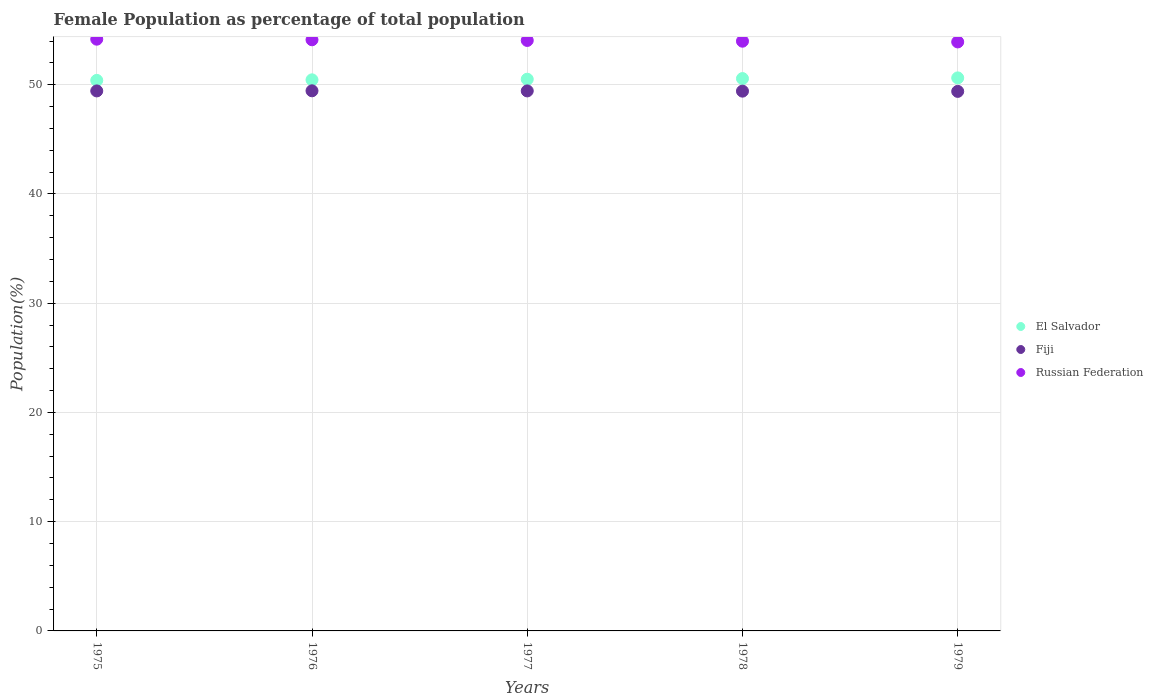How many different coloured dotlines are there?
Provide a short and direct response. 3. What is the female population in in Fiji in 1978?
Your answer should be very brief. 49.41. Across all years, what is the maximum female population in in Russian Federation?
Provide a short and direct response. 54.17. Across all years, what is the minimum female population in in Fiji?
Give a very brief answer. 49.39. In which year was the female population in in Russian Federation maximum?
Ensure brevity in your answer.  1975. In which year was the female population in in El Salvador minimum?
Your response must be concise. 1975. What is the total female population in in Fiji in the graph?
Make the answer very short. 247.11. What is the difference between the female population in in Russian Federation in 1975 and that in 1977?
Give a very brief answer. 0.12. What is the difference between the female population in in Russian Federation in 1975 and the female population in in El Salvador in 1976?
Your answer should be compact. 3.72. What is the average female population in in Russian Federation per year?
Provide a short and direct response. 54.05. In the year 1979, what is the difference between the female population in in El Salvador and female population in in Russian Federation?
Make the answer very short. -3.29. In how many years, is the female population in in El Salvador greater than 22 %?
Offer a terse response. 5. What is the ratio of the female population in in Russian Federation in 1975 to that in 1976?
Keep it short and to the point. 1. What is the difference between the highest and the second highest female population in in Fiji?
Give a very brief answer. 0.01. What is the difference between the highest and the lowest female population in in Fiji?
Keep it short and to the point. 0.05. What is the difference between two consecutive major ticks on the Y-axis?
Make the answer very short. 10. Are the values on the major ticks of Y-axis written in scientific E-notation?
Your answer should be very brief. No. Does the graph contain any zero values?
Your response must be concise. No. Does the graph contain grids?
Keep it short and to the point. Yes. Where does the legend appear in the graph?
Make the answer very short. Center right. How many legend labels are there?
Provide a succinct answer. 3. How are the legend labels stacked?
Give a very brief answer. Vertical. What is the title of the graph?
Offer a terse response. Female Population as percentage of total population. What is the label or title of the Y-axis?
Your answer should be very brief. Population(%). What is the Population(%) of El Salvador in 1975?
Make the answer very short. 50.4. What is the Population(%) of Fiji in 1975?
Keep it short and to the point. 49.43. What is the Population(%) of Russian Federation in 1975?
Provide a succinct answer. 54.17. What is the Population(%) of El Salvador in 1976?
Make the answer very short. 50.45. What is the Population(%) of Fiji in 1976?
Ensure brevity in your answer.  49.44. What is the Population(%) in Russian Federation in 1976?
Provide a succinct answer. 54.11. What is the Population(%) of El Salvador in 1977?
Your response must be concise. 50.5. What is the Population(%) in Fiji in 1977?
Make the answer very short. 49.43. What is the Population(%) in Russian Federation in 1977?
Make the answer very short. 54.05. What is the Population(%) in El Salvador in 1978?
Give a very brief answer. 50.56. What is the Population(%) in Fiji in 1978?
Offer a very short reply. 49.41. What is the Population(%) of Russian Federation in 1978?
Provide a succinct answer. 53.98. What is the Population(%) of El Salvador in 1979?
Offer a very short reply. 50.62. What is the Population(%) of Fiji in 1979?
Your response must be concise. 49.39. What is the Population(%) of Russian Federation in 1979?
Your response must be concise. 53.92. Across all years, what is the maximum Population(%) of El Salvador?
Provide a succinct answer. 50.62. Across all years, what is the maximum Population(%) in Fiji?
Your answer should be compact. 49.44. Across all years, what is the maximum Population(%) in Russian Federation?
Ensure brevity in your answer.  54.17. Across all years, what is the minimum Population(%) of El Salvador?
Provide a short and direct response. 50.4. Across all years, what is the minimum Population(%) of Fiji?
Ensure brevity in your answer.  49.39. Across all years, what is the minimum Population(%) in Russian Federation?
Offer a very short reply. 53.92. What is the total Population(%) of El Salvador in the graph?
Your response must be concise. 252.53. What is the total Population(%) of Fiji in the graph?
Make the answer very short. 247.11. What is the total Population(%) of Russian Federation in the graph?
Give a very brief answer. 270.24. What is the difference between the Population(%) in El Salvador in 1975 and that in 1976?
Keep it short and to the point. -0.05. What is the difference between the Population(%) in Fiji in 1975 and that in 1976?
Offer a very short reply. -0.01. What is the difference between the Population(%) in Russian Federation in 1975 and that in 1976?
Provide a short and direct response. 0.05. What is the difference between the Population(%) in El Salvador in 1975 and that in 1977?
Give a very brief answer. -0.11. What is the difference between the Population(%) in Fiji in 1975 and that in 1977?
Provide a short and direct response. -0. What is the difference between the Population(%) of Russian Federation in 1975 and that in 1977?
Keep it short and to the point. 0.12. What is the difference between the Population(%) of El Salvador in 1975 and that in 1978?
Provide a short and direct response. -0.17. What is the difference between the Population(%) in Fiji in 1975 and that in 1978?
Make the answer very short. 0.02. What is the difference between the Population(%) in Russian Federation in 1975 and that in 1978?
Give a very brief answer. 0.18. What is the difference between the Population(%) of El Salvador in 1975 and that in 1979?
Make the answer very short. -0.23. What is the difference between the Population(%) in Fiji in 1975 and that in 1979?
Make the answer very short. 0.04. What is the difference between the Population(%) in Russian Federation in 1975 and that in 1979?
Your answer should be very brief. 0.25. What is the difference between the Population(%) in El Salvador in 1976 and that in 1977?
Keep it short and to the point. -0.06. What is the difference between the Population(%) of Fiji in 1976 and that in 1977?
Offer a terse response. 0.01. What is the difference between the Population(%) of Russian Federation in 1976 and that in 1977?
Provide a succinct answer. 0.06. What is the difference between the Population(%) in El Salvador in 1976 and that in 1978?
Keep it short and to the point. -0.12. What is the difference between the Population(%) of Fiji in 1976 and that in 1978?
Your answer should be compact. 0.03. What is the difference between the Population(%) of Russian Federation in 1976 and that in 1978?
Your answer should be compact. 0.13. What is the difference between the Population(%) of El Salvador in 1976 and that in 1979?
Make the answer very short. -0.18. What is the difference between the Population(%) in Fiji in 1976 and that in 1979?
Ensure brevity in your answer.  0.05. What is the difference between the Population(%) of Russian Federation in 1976 and that in 1979?
Offer a very short reply. 0.2. What is the difference between the Population(%) of El Salvador in 1977 and that in 1978?
Ensure brevity in your answer.  -0.06. What is the difference between the Population(%) of Fiji in 1977 and that in 1978?
Give a very brief answer. 0.02. What is the difference between the Population(%) in Russian Federation in 1977 and that in 1978?
Keep it short and to the point. 0.07. What is the difference between the Population(%) of El Salvador in 1977 and that in 1979?
Give a very brief answer. -0.12. What is the difference between the Population(%) of Fiji in 1977 and that in 1979?
Keep it short and to the point. 0.04. What is the difference between the Population(%) of Russian Federation in 1977 and that in 1979?
Offer a terse response. 0.13. What is the difference between the Population(%) of El Salvador in 1978 and that in 1979?
Offer a terse response. -0.06. What is the difference between the Population(%) of Fiji in 1978 and that in 1979?
Make the answer very short. 0.02. What is the difference between the Population(%) of Russian Federation in 1978 and that in 1979?
Keep it short and to the point. 0.07. What is the difference between the Population(%) of El Salvador in 1975 and the Population(%) of Fiji in 1976?
Provide a succinct answer. 0.95. What is the difference between the Population(%) in El Salvador in 1975 and the Population(%) in Russian Federation in 1976?
Your answer should be very brief. -3.72. What is the difference between the Population(%) of Fiji in 1975 and the Population(%) of Russian Federation in 1976?
Keep it short and to the point. -4.68. What is the difference between the Population(%) of El Salvador in 1975 and the Population(%) of Fiji in 1977?
Ensure brevity in your answer.  0.96. What is the difference between the Population(%) of El Salvador in 1975 and the Population(%) of Russian Federation in 1977?
Your answer should be very brief. -3.66. What is the difference between the Population(%) in Fiji in 1975 and the Population(%) in Russian Federation in 1977?
Make the answer very short. -4.62. What is the difference between the Population(%) in El Salvador in 1975 and the Population(%) in Fiji in 1978?
Your answer should be compact. 0.98. What is the difference between the Population(%) in El Salvador in 1975 and the Population(%) in Russian Federation in 1978?
Your answer should be compact. -3.59. What is the difference between the Population(%) in Fiji in 1975 and the Population(%) in Russian Federation in 1978?
Offer a very short reply. -4.55. What is the difference between the Population(%) in El Salvador in 1975 and the Population(%) in Fiji in 1979?
Your answer should be very brief. 1.01. What is the difference between the Population(%) in El Salvador in 1975 and the Population(%) in Russian Federation in 1979?
Keep it short and to the point. -3.52. What is the difference between the Population(%) of Fiji in 1975 and the Population(%) of Russian Federation in 1979?
Offer a very short reply. -4.49. What is the difference between the Population(%) in El Salvador in 1976 and the Population(%) in Russian Federation in 1977?
Keep it short and to the point. -3.6. What is the difference between the Population(%) in Fiji in 1976 and the Population(%) in Russian Federation in 1977?
Keep it short and to the point. -4.61. What is the difference between the Population(%) of El Salvador in 1976 and the Population(%) of Fiji in 1978?
Keep it short and to the point. 1.04. What is the difference between the Population(%) of El Salvador in 1976 and the Population(%) of Russian Federation in 1978?
Give a very brief answer. -3.54. What is the difference between the Population(%) in Fiji in 1976 and the Population(%) in Russian Federation in 1978?
Your answer should be very brief. -4.54. What is the difference between the Population(%) of El Salvador in 1976 and the Population(%) of Fiji in 1979?
Ensure brevity in your answer.  1.06. What is the difference between the Population(%) in El Salvador in 1976 and the Population(%) in Russian Federation in 1979?
Provide a succinct answer. -3.47. What is the difference between the Population(%) in Fiji in 1976 and the Population(%) in Russian Federation in 1979?
Offer a very short reply. -4.47. What is the difference between the Population(%) of El Salvador in 1977 and the Population(%) of Fiji in 1978?
Offer a very short reply. 1.09. What is the difference between the Population(%) of El Salvador in 1977 and the Population(%) of Russian Federation in 1978?
Your answer should be very brief. -3.48. What is the difference between the Population(%) of Fiji in 1977 and the Population(%) of Russian Federation in 1978?
Your answer should be compact. -4.55. What is the difference between the Population(%) of El Salvador in 1977 and the Population(%) of Fiji in 1979?
Give a very brief answer. 1.11. What is the difference between the Population(%) of El Salvador in 1977 and the Population(%) of Russian Federation in 1979?
Ensure brevity in your answer.  -3.41. What is the difference between the Population(%) in Fiji in 1977 and the Population(%) in Russian Federation in 1979?
Your answer should be compact. -4.48. What is the difference between the Population(%) of El Salvador in 1978 and the Population(%) of Fiji in 1979?
Keep it short and to the point. 1.17. What is the difference between the Population(%) of El Salvador in 1978 and the Population(%) of Russian Federation in 1979?
Provide a short and direct response. -3.35. What is the difference between the Population(%) of Fiji in 1978 and the Population(%) of Russian Federation in 1979?
Give a very brief answer. -4.51. What is the average Population(%) of El Salvador per year?
Your answer should be very brief. 50.51. What is the average Population(%) of Fiji per year?
Provide a succinct answer. 49.42. What is the average Population(%) in Russian Federation per year?
Offer a terse response. 54.05. In the year 1975, what is the difference between the Population(%) in El Salvador and Population(%) in Fiji?
Provide a succinct answer. 0.96. In the year 1975, what is the difference between the Population(%) of El Salvador and Population(%) of Russian Federation?
Provide a short and direct response. -3.77. In the year 1975, what is the difference between the Population(%) in Fiji and Population(%) in Russian Federation?
Provide a short and direct response. -4.74. In the year 1976, what is the difference between the Population(%) in El Salvador and Population(%) in Russian Federation?
Provide a short and direct response. -3.67. In the year 1976, what is the difference between the Population(%) of Fiji and Population(%) of Russian Federation?
Your answer should be compact. -4.67. In the year 1977, what is the difference between the Population(%) of El Salvador and Population(%) of Fiji?
Your answer should be compact. 1.07. In the year 1977, what is the difference between the Population(%) in El Salvador and Population(%) in Russian Federation?
Make the answer very short. -3.55. In the year 1977, what is the difference between the Population(%) in Fiji and Population(%) in Russian Federation?
Offer a terse response. -4.62. In the year 1978, what is the difference between the Population(%) of El Salvador and Population(%) of Fiji?
Keep it short and to the point. 1.15. In the year 1978, what is the difference between the Population(%) of El Salvador and Population(%) of Russian Federation?
Offer a very short reply. -3.42. In the year 1978, what is the difference between the Population(%) in Fiji and Population(%) in Russian Federation?
Your answer should be very brief. -4.57. In the year 1979, what is the difference between the Population(%) of El Salvador and Population(%) of Fiji?
Keep it short and to the point. 1.23. In the year 1979, what is the difference between the Population(%) in El Salvador and Population(%) in Russian Federation?
Your answer should be compact. -3.29. In the year 1979, what is the difference between the Population(%) of Fiji and Population(%) of Russian Federation?
Provide a short and direct response. -4.53. What is the ratio of the Population(%) of El Salvador in 1975 to that in 1976?
Give a very brief answer. 1. What is the ratio of the Population(%) of Fiji in 1975 to that in 1976?
Provide a succinct answer. 1. What is the ratio of the Population(%) of Russian Federation in 1975 to that in 1976?
Make the answer very short. 1. What is the ratio of the Population(%) of El Salvador in 1975 to that in 1977?
Provide a succinct answer. 1. What is the ratio of the Population(%) in Fiji in 1975 to that in 1977?
Offer a very short reply. 1. What is the ratio of the Population(%) in Fiji in 1975 to that in 1978?
Your response must be concise. 1. What is the ratio of the Population(%) of El Salvador in 1975 to that in 1979?
Provide a short and direct response. 1. What is the ratio of the Population(%) of Russian Federation in 1975 to that in 1979?
Your response must be concise. 1. What is the ratio of the Population(%) in El Salvador in 1976 to that in 1977?
Provide a succinct answer. 1. What is the ratio of the Population(%) of Russian Federation in 1976 to that in 1979?
Provide a succinct answer. 1. What is the ratio of the Population(%) of El Salvador in 1977 to that in 1978?
Keep it short and to the point. 1. What is the ratio of the Population(%) in Russian Federation in 1977 to that in 1979?
Offer a terse response. 1. What is the ratio of the Population(%) of El Salvador in 1978 to that in 1979?
Ensure brevity in your answer.  1. What is the ratio of the Population(%) in Fiji in 1978 to that in 1979?
Your answer should be compact. 1. What is the ratio of the Population(%) of Russian Federation in 1978 to that in 1979?
Ensure brevity in your answer.  1. What is the difference between the highest and the second highest Population(%) of El Salvador?
Offer a very short reply. 0.06. What is the difference between the highest and the second highest Population(%) of Fiji?
Offer a very short reply. 0.01. What is the difference between the highest and the second highest Population(%) of Russian Federation?
Your answer should be very brief. 0.05. What is the difference between the highest and the lowest Population(%) in El Salvador?
Provide a succinct answer. 0.23. What is the difference between the highest and the lowest Population(%) of Fiji?
Offer a very short reply. 0.05. What is the difference between the highest and the lowest Population(%) in Russian Federation?
Provide a succinct answer. 0.25. 